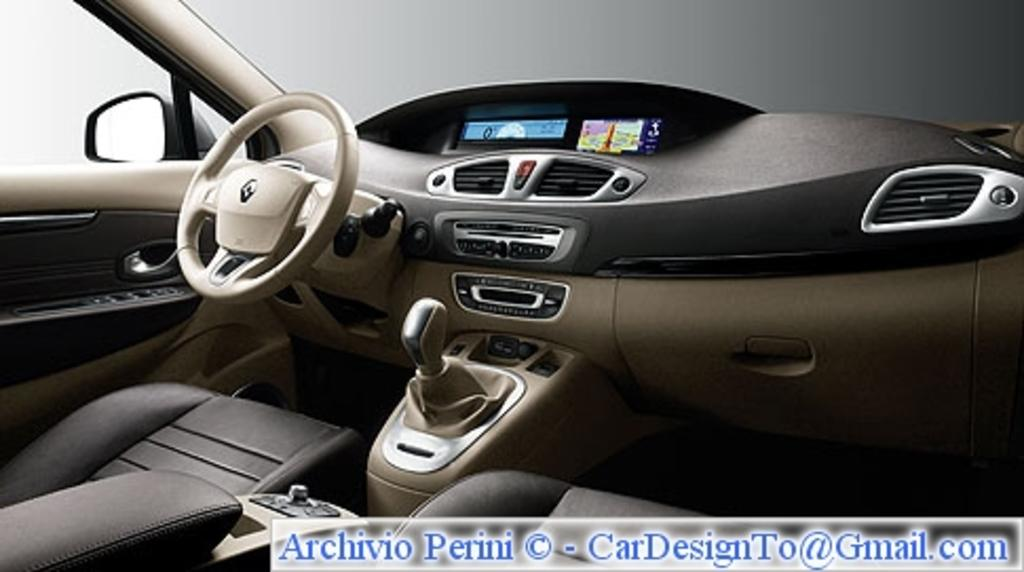What is the primary component of the vehicle in the image? The image contains a driver seat. What is used to control the direction of the vehicle? There is a steering wheel in the image. What is used to change gears in the vehicle? A clutch and a gear are present in the image. What is used to play music in the vehicle? A music system is visible in the image. How is air circulation managed in the vehicle? There is an air vent in the image. What is used to check the rear view while driving? A mirror is present in the image. What protects the driver from external elements while driving? A windshield is visible in the image. Where are the tomatoes stored in the image? There are no tomatoes present in the image. What type of lamp is used to illuminate the interior of the vehicle in the image? There is no lamp present in the image. 